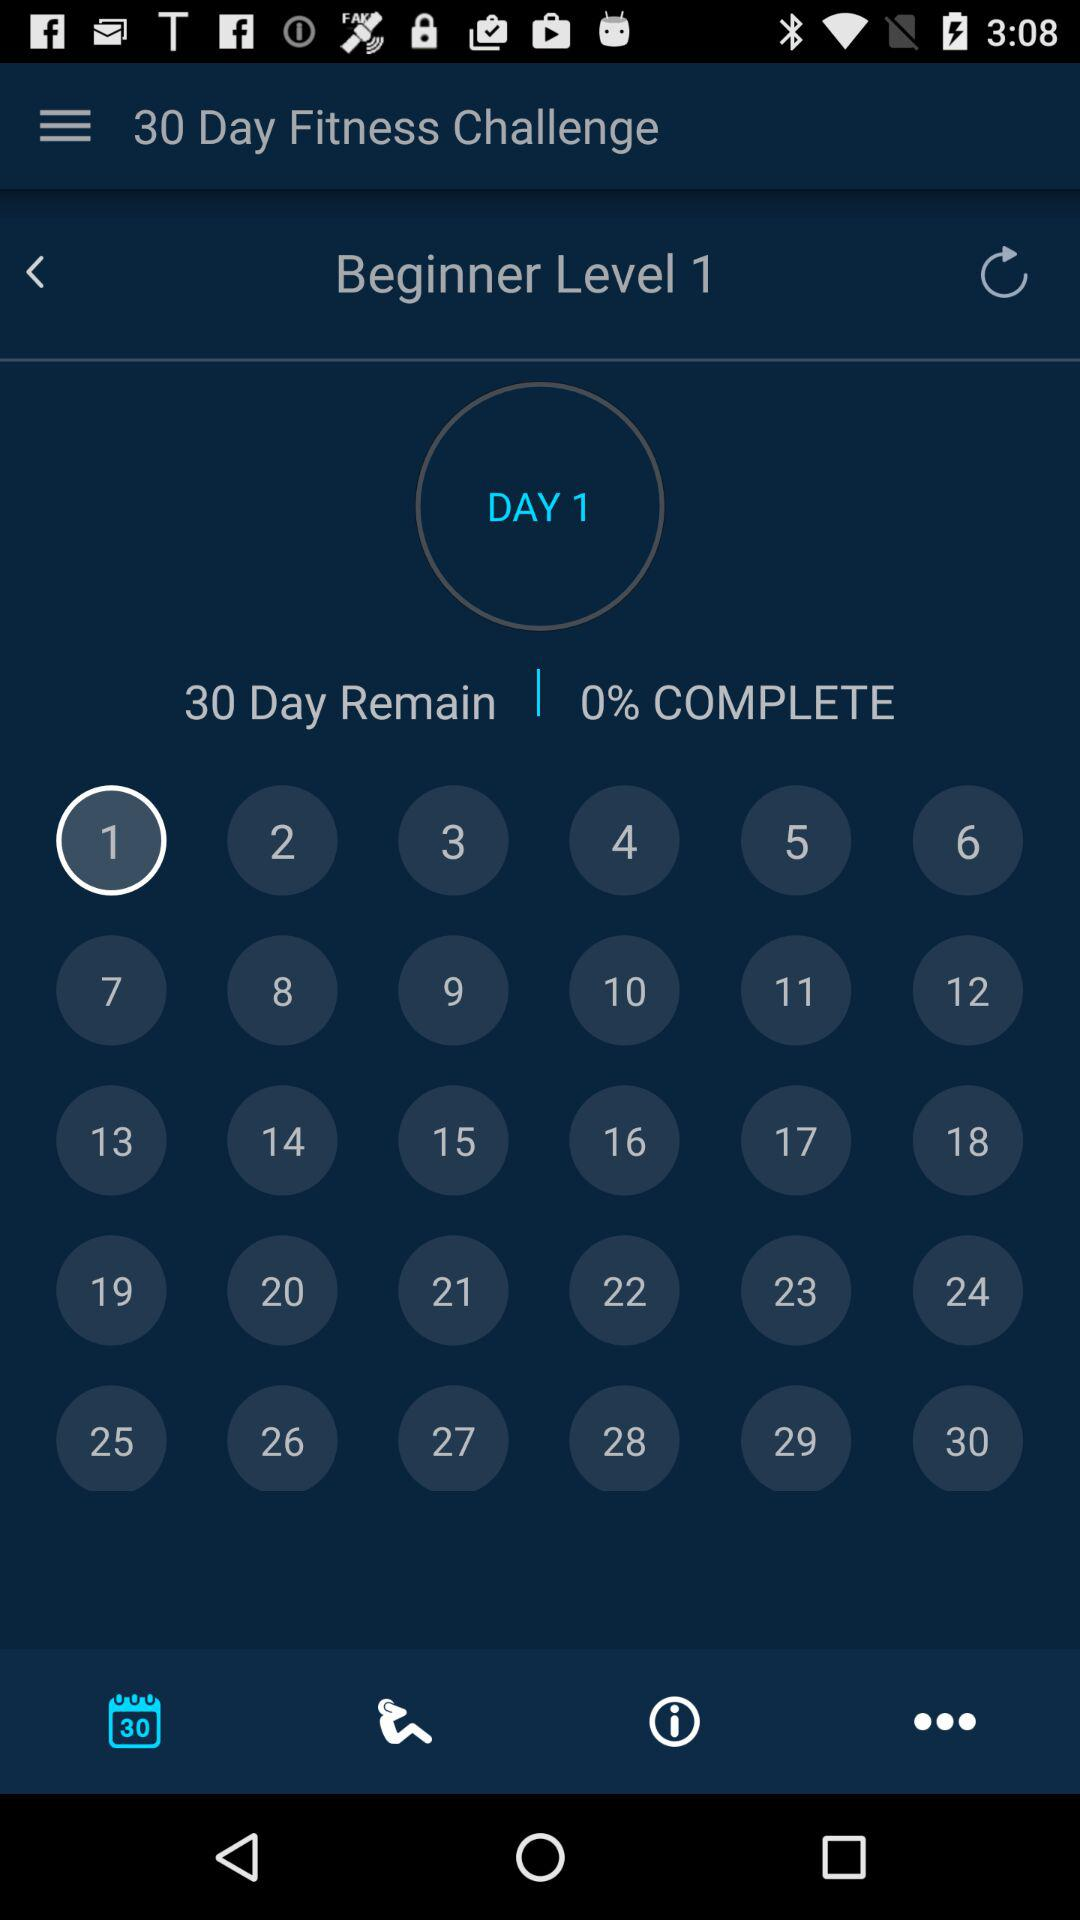How many days have been completed?
Answer the question using a single word or phrase. 0 